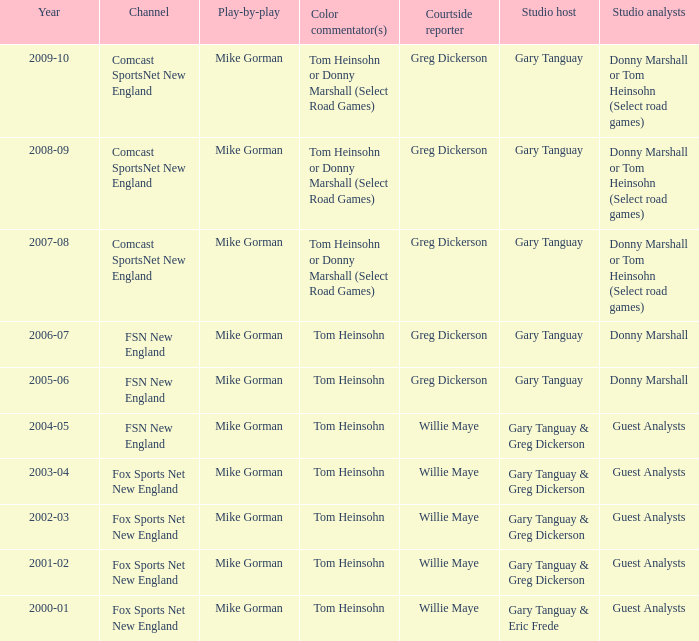Which studio anchor has a year of 2003-04? Gary Tanguay & Greg Dickerson. 